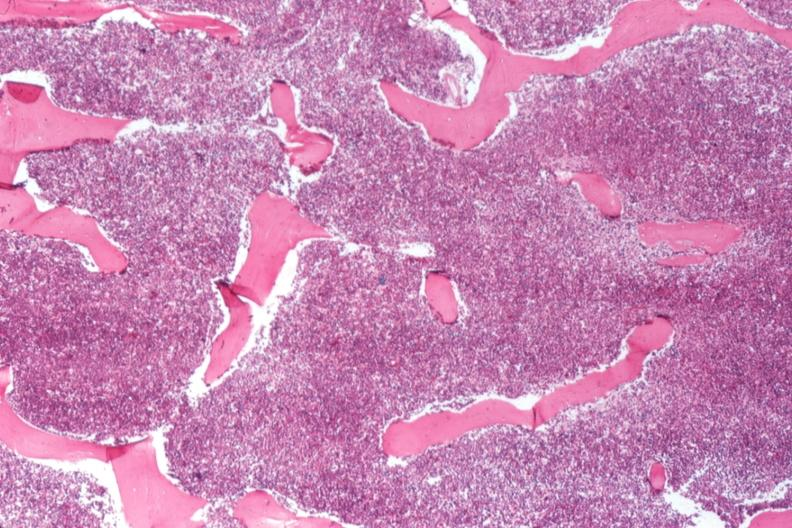does this image show 100 % cellular marrow?
Answer the question using a single word or phrase. Yes 